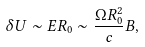<formula> <loc_0><loc_0><loc_500><loc_500>\delta U \sim E R _ { 0 } \sim \frac { \Omega R _ { 0 } ^ { 2 } } { c } B ,</formula> 